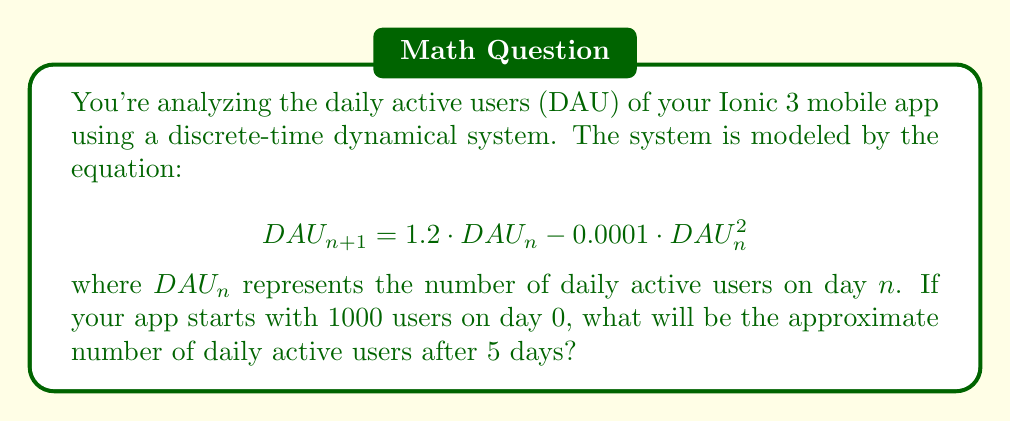Help me with this question. To solve this problem, we need to iterate the given equation for 5 days, starting with the initial condition $DAU_0 = 1000$.

Step 1: Calculate $DAU_1$
$$DAU_1 = 1.2 \cdot 1000 - 0.0001 \cdot 1000^2 = 1200 - 100 = 1100$$

Step 2: Calculate $DAU_2$
$$DAU_2 = 1.2 \cdot 1100 - 0.0001 \cdot 1100^2 = 1320 - 121 = 1199$$

Step 3: Calculate $DAU_3$
$$DAU_3 = 1.2 \cdot 1199 - 0.0001 \cdot 1199^2 = 1438.8 - 143.76 \approx 1295$$

Step 4: Calculate $DAU_4$
$$DAU_4 = 1.2 \cdot 1295 - 0.0001 \cdot 1295^2 = 1554 - 167.7 \approx 1386$$

Step 5: Calculate $DAU_5$
$$DAU_5 = 1.2 \cdot 1386 - 0.0001 \cdot 1386^2 = 1663.2 - 192.1 \approx 1471$$

Therefore, after 5 days, the approximate number of daily active users will be 1471.
Answer: 1471 users 